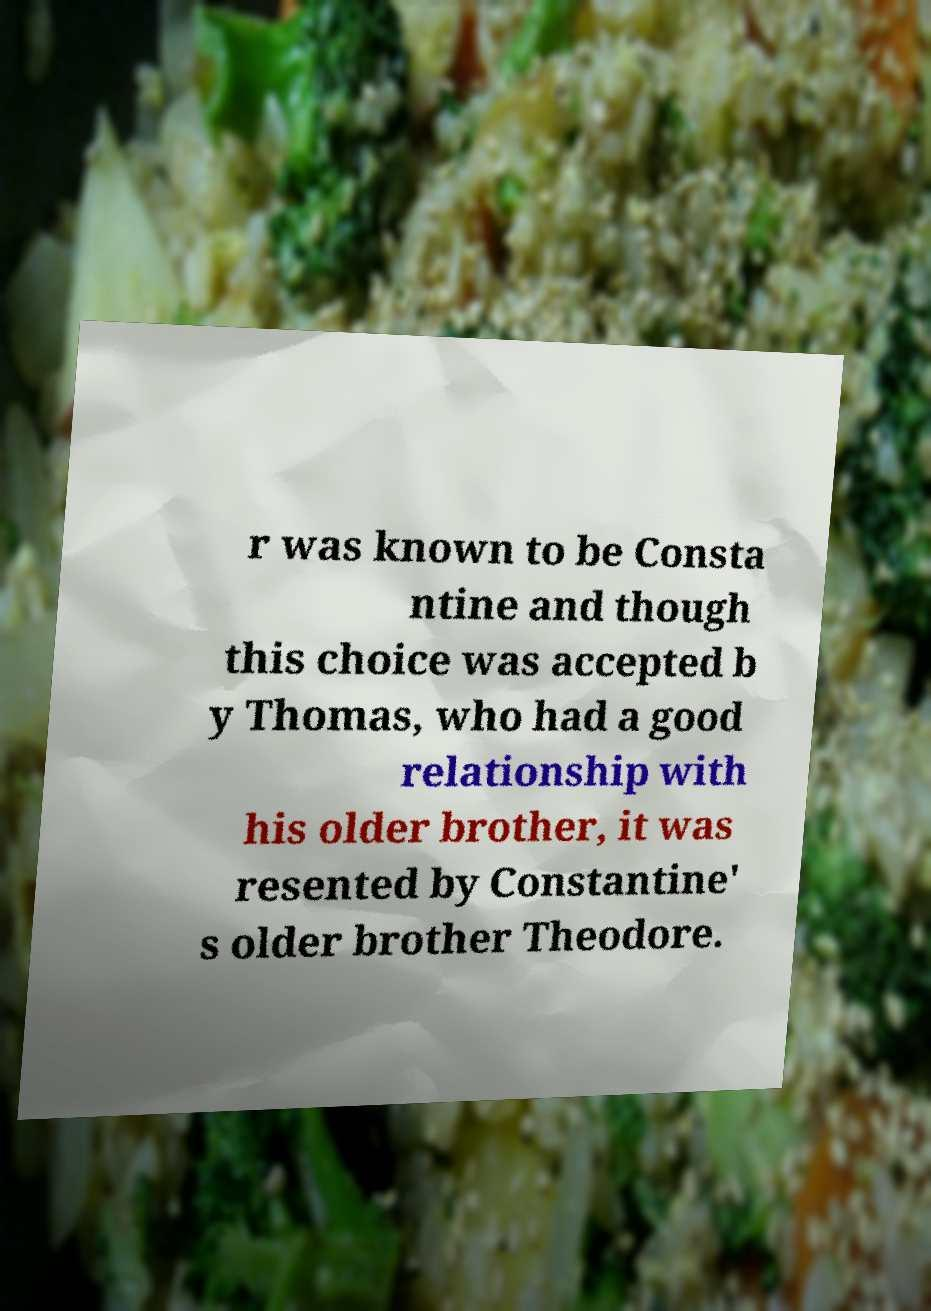Please read and relay the text visible in this image. What does it say? r was known to be Consta ntine and though this choice was accepted b y Thomas, who had a good relationship with his older brother, it was resented by Constantine' s older brother Theodore. 